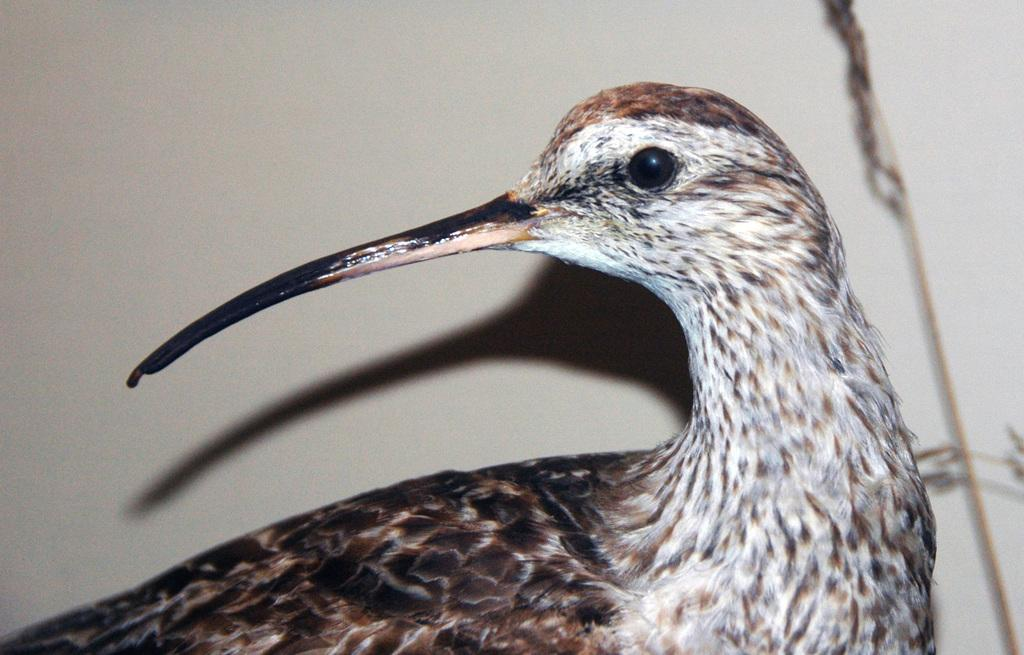What type of animal is in the image? There is a bird in the image. What is unique about the bird's appearance? The bird has a long beak. What color is the bird? The bird is brown in color. What can be seen in the background of the image? There is a wall in the background of the image. What other element is present in the image? There is a small stem of a plant on the right side of the image. What type of fuel is the bird using to fly in the image? The image does not show the bird flying, and there is no mention of fuel in the facts provided. 